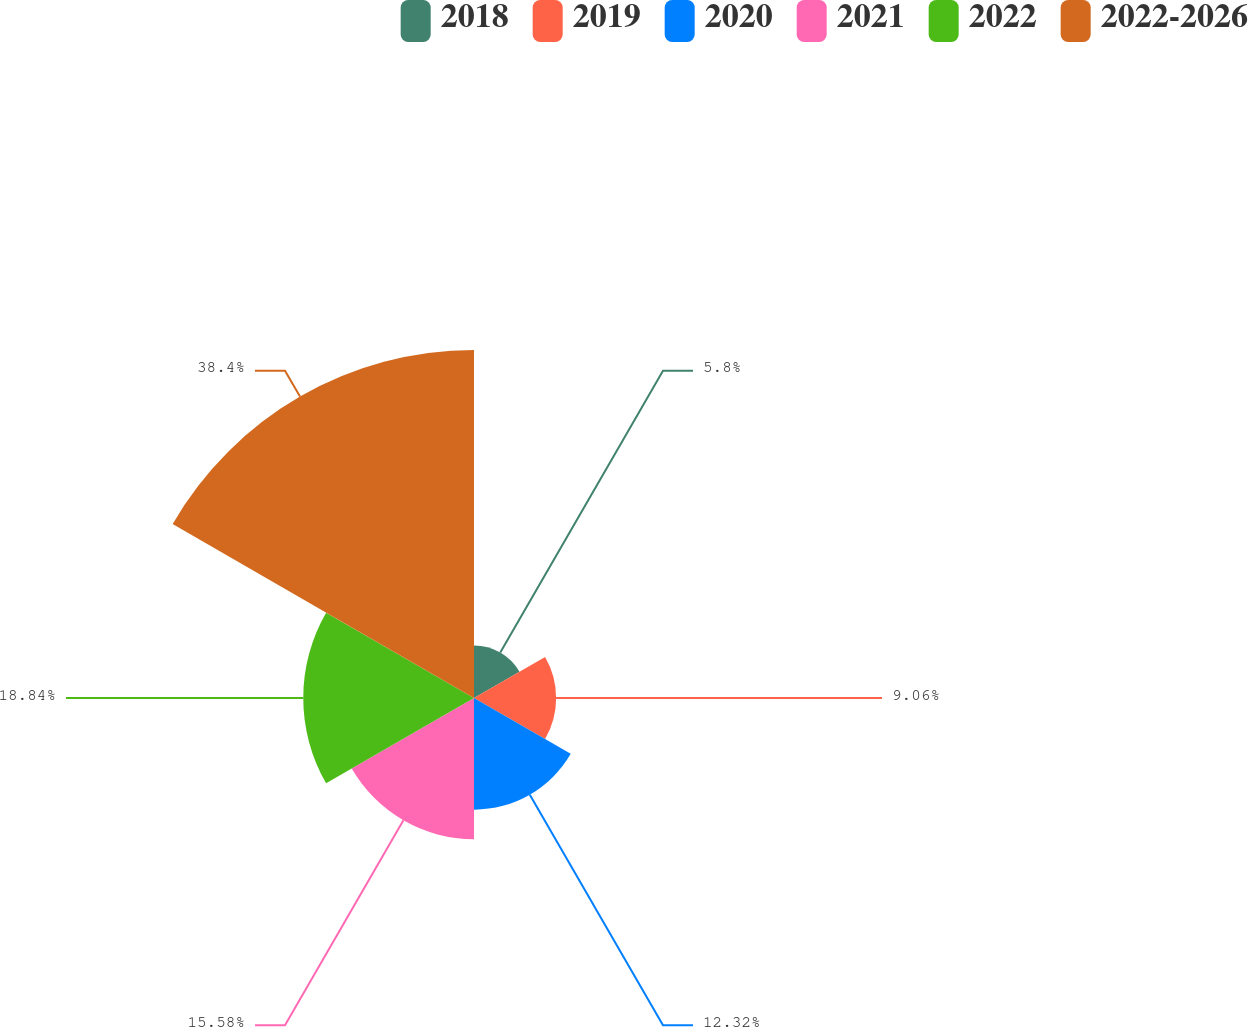<chart> <loc_0><loc_0><loc_500><loc_500><pie_chart><fcel>2018<fcel>2019<fcel>2020<fcel>2021<fcel>2022<fcel>2022-2026<nl><fcel>5.8%<fcel>9.06%<fcel>12.32%<fcel>15.58%<fcel>18.84%<fcel>38.4%<nl></chart> 